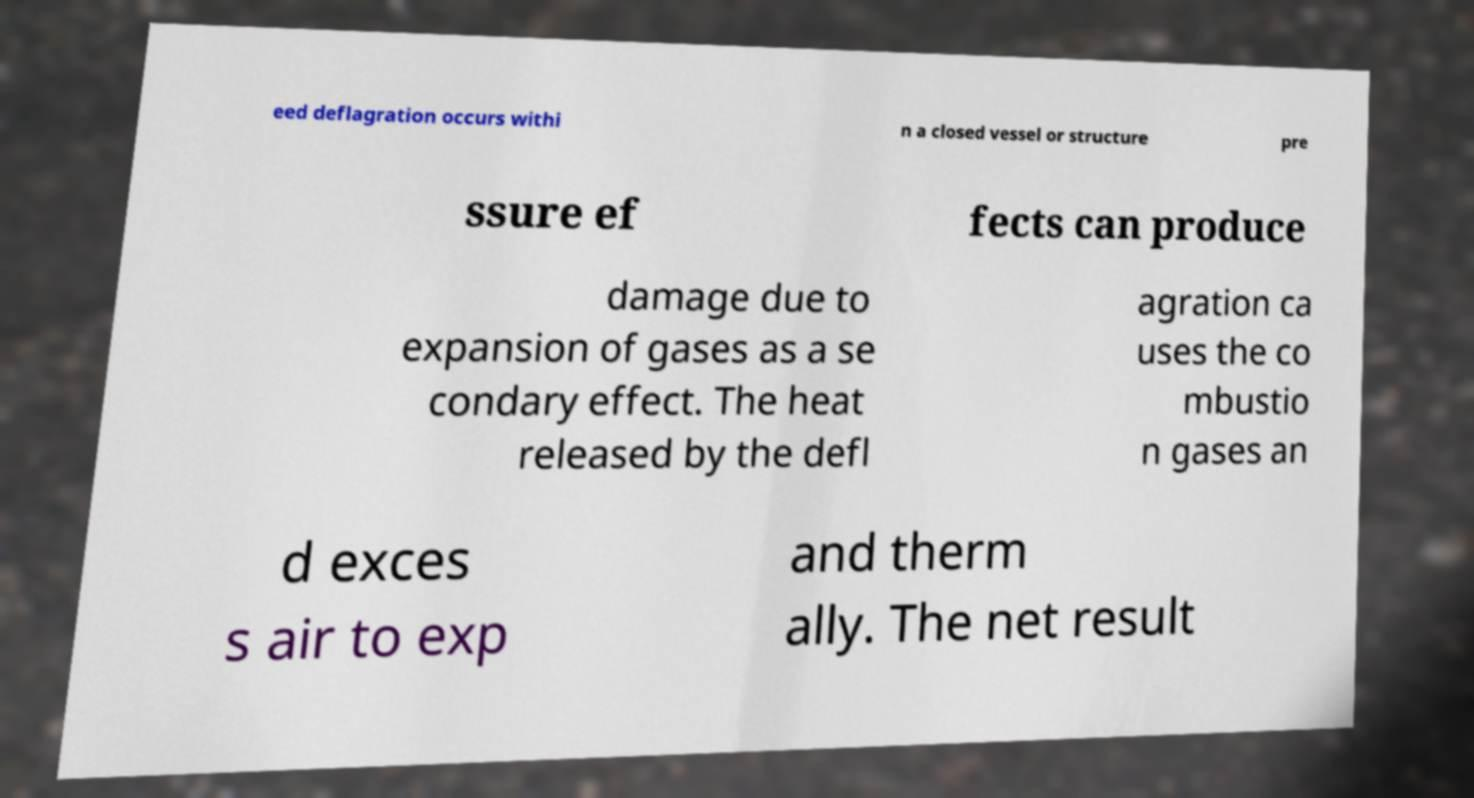What messages or text are displayed in this image? I need them in a readable, typed format. eed deflagration occurs withi n a closed vessel or structure pre ssure ef fects can produce damage due to expansion of gases as a se condary effect. The heat released by the defl agration ca uses the co mbustio n gases an d exces s air to exp and therm ally. The net result 